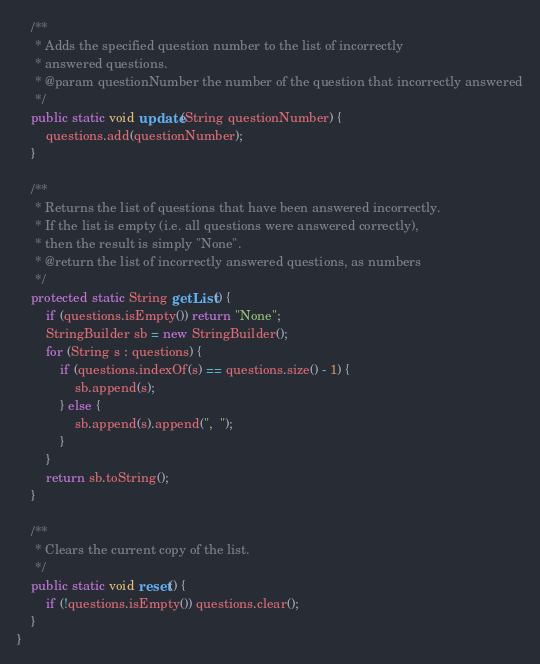<code> <loc_0><loc_0><loc_500><loc_500><_Java_>	/**
	 * Adds the specified question number to the list of incorrectly 
	 * answered questions. 
	 * @param questionNumber the number of the question that incorrectly answered
	 */
	public static void update(String questionNumber) {
		questions.add(questionNumber);
	}
	
	/**
	 * Returns the list of questions that have been answered incorrectly. 
	 * If the list is empty (i.e. all questions were answered correctly), 
	 * then the result is simply "None".
	 * @return the list of incorrectly answered questions, as numbers
	 */
	protected static String getList() {
		if (questions.isEmpty()) return "None"; 
		StringBuilder sb = new StringBuilder();
		for (String s : questions) {
			if (questions.indexOf(s) == questions.size() - 1) {
				sb.append(s); 
			} else {
				sb.append(s).append(",  "); 
			}
		}
		return sb.toString(); 
	}
	
	/**
	 * Clears the current copy of the list. 
	 */
	public static void reset() {
		if (!questions.isEmpty()) questions.clear(); 
	}
}
</code> 